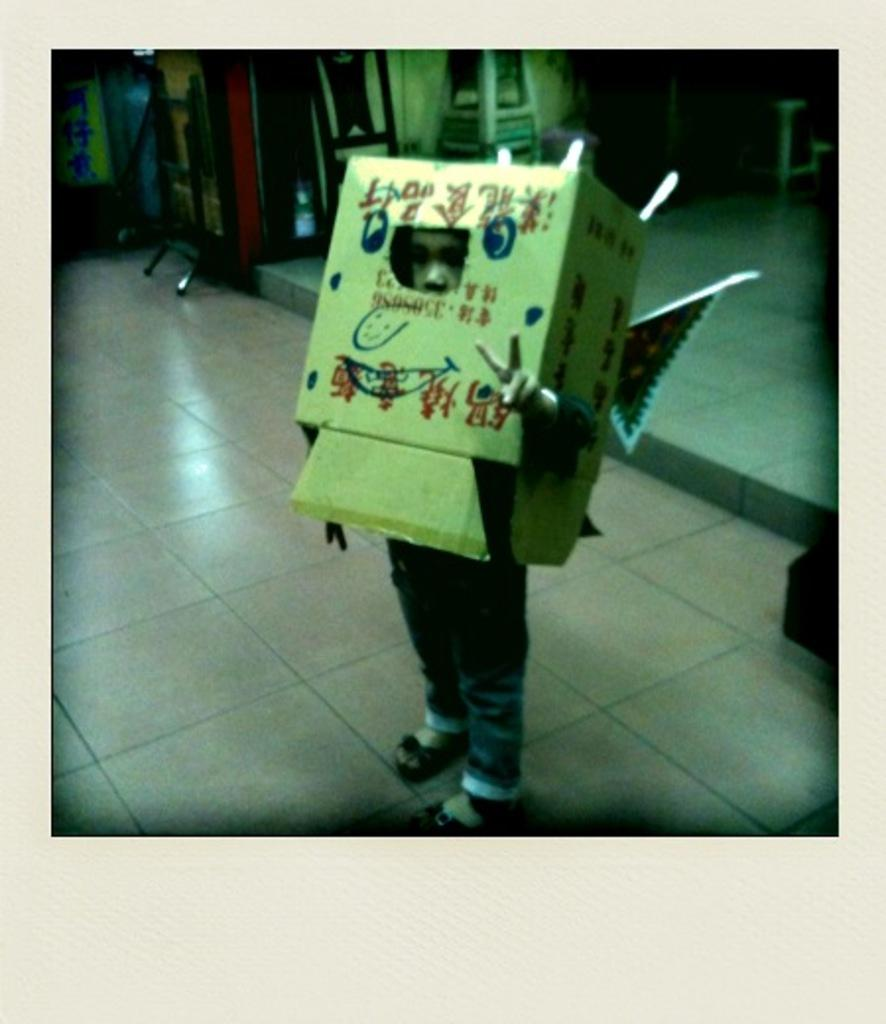What is the main subject of the image? The main subject of the image is a boy. Where is the boy located in the image? The boy is standing on the floor in the image. What is the boy doing with the packing box? The boy has covered his face with a packing box. What type of skirt is the boy wearing in the image? The boy is not wearing a skirt in the image; he is wearing a covering over his face with a packing box. 